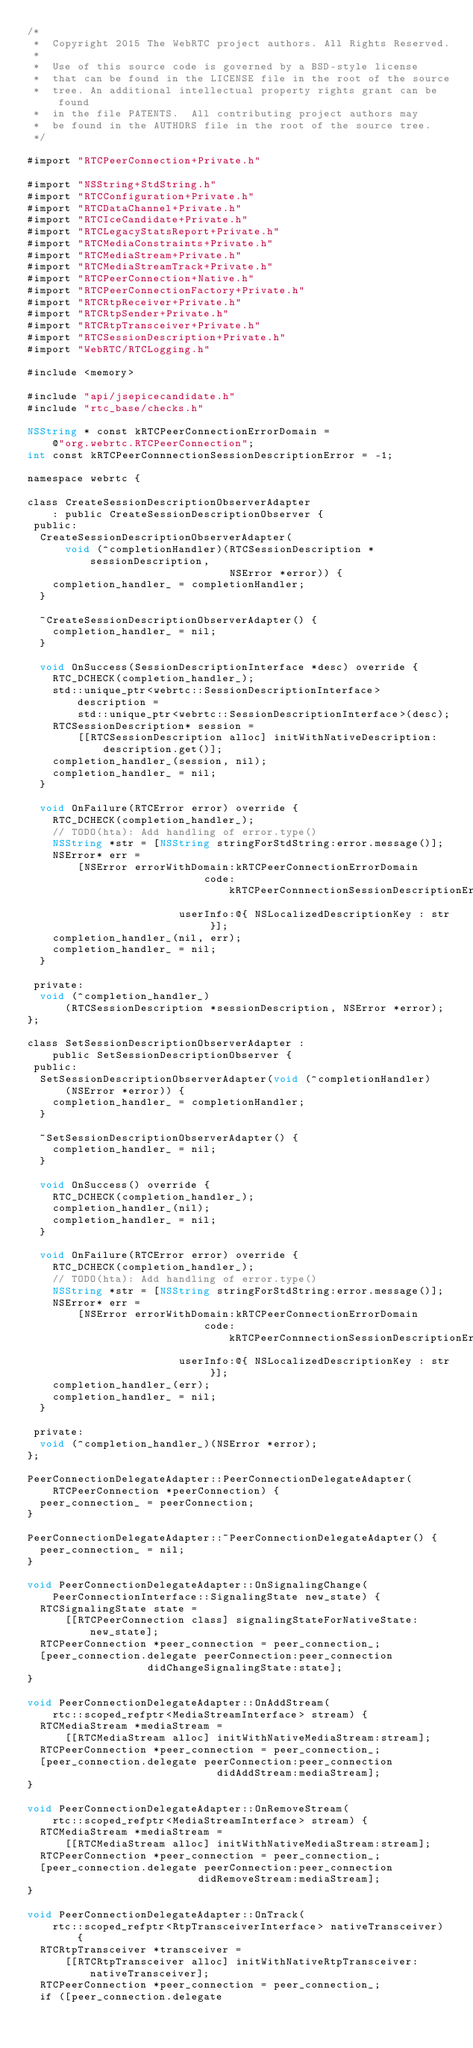Convert code to text. <code><loc_0><loc_0><loc_500><loc_500><_ObjectiveC_>/*
 *  Copyright 2015 The WebRTC project authors. All Rights Reserved.
 *
 *  Use of this source code is governed by a BSD-style license
 *  that can be found in the LICENSE file in the root of the source
 *  tree. An additional intellectual property rights grant can be found
 *  in the file PATENTS.  All contributing project authors may
 *  be found in the AUTHORS file in the root of the source tree.
 */

#import "RTCPeerConnection+Private.h"

#import "NSString+StdString.h"
#import "RTCConfiguration+Private.h"
#import "RTCDataChannel+Private.h"
#import "RTCIceCandidate+Private.h"
#import "RTCLegacyStatsReport+Private.h"
#import "RTCMediaConstraints+Private.h"
#import "RTCMediaStream+Private.h"
#import "RTCMediaStreamTrack+Private.h"
#import "RTCPeerConnection+Native.h"
#import "RTCPeerConnectionFactory+Private.h"
#import "RTCRtpReceiver+Private.h"
#import "RTCRtpSender+Private.h"
#import "RTCRtpTransceiver+Private.h"
#import "RTCSessionDescription+Private.h"
#import "WebRTC/RTCLogging.h"

#include <memory>

#include "api/jsepicecandidate.h"
#include "rtc_base/checks.h"

NSString * const kRTCPeerConnectionErrorDomain =
    @"org.webrtc.RTCPeerConnection";
int const kRTCPeerConnnectionSessionDescriptionError = -1;

namespace webrtc {

class CreateSessionDescriptionObserverAdapter
    : public CreateSessionDescriptionObserver {
 public:
  CreateSessionDescriptionObserverAdapter(
      void (^completionHandler)(RTCSessionDescription *sessionDescription,
                                NSError *error)) {
    completion_handler_ = completionHandler;
  }

  ~CreateSessionDescriptionObserverAdapter() {
    completion_handler_ = nil;
  }

  void OnSuccess(SessionDescriptionInterface *desc) override {
    RTC_DCHECK(completion_handler_);
    std::unique_ptr<webrtc::SessionDescriptionInterface> description =
        std::unique_ptr<webrtc::SessionDescriptionInterface>(desc);
    RTCSessionDescription* session =
        [[RTCSessionDescription alloc] initWithNativeDescription:
            description.get()];
    completion_handler_(session, nil);
    completion_handler_ = nil;
  }

  void OnFailure(RTCError error) override {
    RTC_DCHECK(completion_handler_);
    // TODO(hta): Add handling of error.type()
    NSString *str = [NSString stringForStdString:error.message()];
    NSError* err =
        [NSError errorWithDomain:kRTCPeerConnectionErrorDomain
                            code:kRTCPeerConnnectionSessionDescriptionError
                        userInfo:@{ NSLocalizedDescriptionKey : str }];
    completion_handler_(nil, err);
    completion_handler_ = nil;
  }

 private:
  void (^completion_handler_)
      (RTCSessionDescription *sessionDescription, NSError *error);
};

class SetSessionDescriptionObserverAdapter :
    public SetSessionDescriptionObserver {
 public:
  SetSessionDescriptionObserverAdapter(void (^completionHandler)
      (NSError *error)) {
    completion_handler_ = completionHandler;
  }

  ~SetSessionDescriptionObserverAdapter() {
    completion_handler_ = nil;
  }

  void OnSuccess() override {
    RTC_DCHECK(completion_handler_);
    completion_handler_(nil);
    completion_handler_ = nil;
  }

  void OnFailure(RTCError error) override {
    RTC_DCHECK(completion_handler_);
    // TODO(hta): Add handling of error.type()
    NSString *str = [NSString stringForStdString:error.message()];
    NSError* err =
        [NSError errorWithDomain:kRTCPeerConnectionErrorDomain
                            code:kRTCPeerConnnectionSessionDescriptionError
                        userInfo:@{ NSLocalizedDescriptionKey : str }];
    completion_handler_(err);
    completion_handler_ = nil;
  }

 private:
  void (^completion_handler_)(NSError *error);
};

PeerConnectionDelegateAdapter::PeerConnectionDelegateAdapter(
    RTCPeerConnection *peerConnection) {
  peer_connection_ = peerConnection;
}

PeerConnectionDelegateAdapter::~PeerConnectionDelegateAdapter() {
  peer_connection_ = nil;
}

void PeerConnectionDelegateAdapter::OnSignalingChange(
    PeerConnectionInterface::SignalingState new_state) {
  RTCSignalingState state =
      [[RTCPeerConnection class] signalingStateForNativeState:new_state];
  RTCPeerConnection *peer_connection = peer_connection_;
  [peer_connection.delegate peerConnection:peer_connection
                   didChangeSignalingState:state];
}

void PeerConnectionDelegateAdapter::OnAddStream(
    rtc::scoped_refptr<MediaStreamInterface> stream) {
  RTCMediaStream *mediaStream =
      [[RTCMediaStream alloc] initWithNativeMediaStream:stream];
  RTCPeerConnection *peer_connection = peer_connection_;
  [peer_connection.delegate peerConnection:peer_connection
                              didAddStream:mediaStream];
}

void PeerConnectionDelegateAdapter::OnRemoveStream(
    rtc::scoped_refptr<MediaStreamInterface> stream) {
  RTCMediaStream *mediaStream =
      [[RTCMediaStream alloc] initWithNativeMediaStream:stream];
  RTCPeerConnection *peer_connection = peer_connection_;
  [peer_connection.delegate peerConnection:peer_connection
                           didRemoveStream:mediaStream];
}

void PeerConnectionDelegateAdapter::OnTrack(
    rtc::scoped_refptr<RtpTransceiverInterface> nativeTransceiver) {
  RTCRtpTransceiver *transceiver =
      [[RTCRtpTransceiver alloc] initWithNativeRtpTransceiver:nativeTransceiver];
  RTCPeerConnection *peer_connection = peer_connection_;
  if ([peer_connection.delegate</code> 